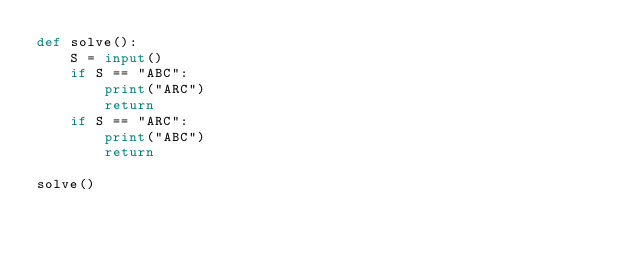<code> <loc_0><loc_0><loc_500><loc_500><_Python_>def solve():
    S = input()
    if S == "ABC":
        print("ARC")
        return
    if S == "ARC":
        print("ABC")
        return

solve()</code> 